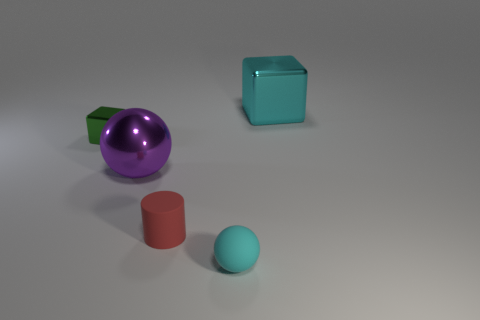What number of metal things are either tiny cyan blocks or large cyan things?
Your answer should be very brief. 1. There is a block that is the same size as the red rubber thing; what is it made of?
Your answer should be very brief. Metal. What number of other objects are the same material as the big cyan thing?
Provide a short and direct response. 2. Are there fewer large cyan cubes right of the large cyan thing than tiny blue shiny blocks?
Give a very brief answer. No. Do the red rubber thing and the purple object have the same shape?
Offer a terse response. No. There is a block that is on the right side of the metallic cube left of the shiny cube that is to the right of the red cylinder; what is its size?
Give a very brief answer. Large. There is a small object that is the same shape as the big purple metallic thing; what material is it?
Keep it short and to the point. Rubber. There is a sphere left of the cyan thing on the left side of the big cyan cube; what size is it?
Offer a very short reply. Large. What color is the rubber sphere?
Make the answer very short. Cyan. How many tiny balls are behind the sphere in front of the purple metallic ball?
Give a very brief answer. 0. 